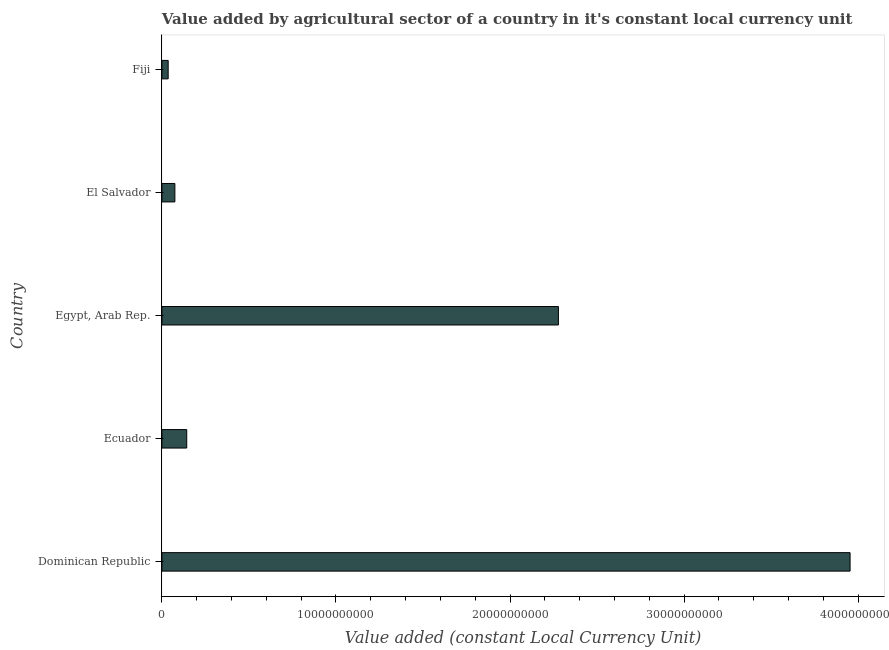Does the graph contain any zero values?
Your answer should be compact. No. What is the title of the graph?
Offer a terse response. Value added by agricultural sector of a country in it's constant local currency unit. What is the label or title of the X-axis?
Give a very brief answer. Value added (constant Local Currency Unit). What is the value added by agriculture sector in Fiji?
Provide a short and direct response. 3.60e+08. Across all countries, what is the maximum value added by agriculture sector?
Your answer should be compact. 3.95e+1. Across all countries, what is the minimum value added by agriculture sector?
Offer a terse response. 3.60e+08. In which country was the value added by agriculture sector maximum?
Ensure brevity in your answer.  Dominican Republic. In which country was the value added by agriculture sector minimum?
Your answer should be very brief. Fiji. What is the sum of the value added by agriculture sector?
Provide a short and direct response. 6.48e+1. What is the difference between the value added by agriculture sector in Egypt, Arab Rep. and El Salvador?
Make the answer very short. 2.20e+1. What is the average value added by agriculture sector per country?
Give a very brief answer. 1.30e+1. What is the median value added by agriculture sector?
Your answer should be compact. 1.43e+09. What is the ratio of the value added by agriculture sector in Dominican Republic to that in Fiji?
Give a very brief answer. 109.82. What is the difference between the highest and the second highest value added by agriculture sector?
Offer a terse response. 1.68e+1. What is the difference between the highest and the lowest value added by agriculture sector?
Your answer should be very brief. 3.92e+1. In how many countries, is the value added by agriculture sector greater than the average value added by agriculture sector taken over all countries?
Provide a succinct answer. 2. How many countries are there in the graph?
Offer a very short reply. 5. What is the Value added (constant Local Currency Unit) in Dominican Republic?
Ensure brevity in your answer.  3.95e+1. What is the Value added (constant Local Currency Unit) of Ecuador?
Ensure brevity in your answer.  1.43e+09. What is the Value added (constant Local Currency Unit) of Egypt, Arab Rep.?
Make the answer very short. 2.28e+1. What is the Value added (constant Local Currency Unit) in El Salvador?
Make the answer very short. 7.45e+08. What is the Value added (constant Local Currency Unit) of Fiji?
Provide a succinct answer. 3.60e+08. What is the difference between the Value added (constant Local Currency Unit) in Dominican Republic and Ecuador?
Provide a short and direct response. 3.81e+1. What is the difference between the Value added (constant Local Currency Unit) in Dominican Republic and Egypt, Arab Rep.?
Provide a short and direct response. 1.68e+1. What is the difference between the Value added (constant Local Currency Unit) in Dominican Republic and El Salvador?
Make the answer very short. 3.88e+1. What is the difference between the Value added (constant Local Currency Unit) in Dominican Republic and Fiji?
Provide a short and direct response. 3.92e+1. What is the difference between the Value added (constant Local Currency Unit) in Ecuador and Egypt, Arab Rep.?
Your response must be concise. -2.14e+1. What is the difference between the Value added (constant Local Currency Unit) in Ecuador and El Salvador?
Provide a short and direct response. 6.81e+08. What is the difference between the Value added (constant Local Currency Unit) in Ecuador and Fiji?
Your answer should be very brief. 1.07e+09. What is the difference between the Value added (constant Local Currency Unit) in Egypt, Arab Rep. and El Salvador?
Provide a succinct answer. 2.20e+1. What is the difference between the Value added (constant Local Currency Unit) in Egypt, Arab Rep. and Fiji?
Offer a very short reply. 2.24e+1. What is the difference between the Value added (constant Local Currency Unit) in El Salvador and Fiji?
Your answer should be compact. 3.85e+08. What is the ratio of the Value added (constant Local Currency Unit) in Dominican Republic to that in Ecuador?
Offer a terse response. 27.71. What is the ratio of the Value added (constant Local Currency Unit) in Dominican Republic to that in Egypt, Arab Rep.?
Your response must be concise. 1.74. What is the ratio of the Value added (constant Local Currency Unit) in Dominican Republic to that in El Salvador?
Give a very brief answer. 53.05. What is the ratio of the Value added (constant Local Currency Unit) in Dominican Republic to that in Fiji?
Your answer should be very brief. 109.82. What is the ratio of the Value added (constant Local Currency Unit) in Ecuador to that in Egypt, Arab Rep.?
Your answer should be very brief. 0.06. What is the ratio of the Value added (constant Local Currency Unit) in Ecuador to that in El Salvador?
Provide a short and direct response. 1.92. What is the ratio of the Value added (constant Local Currency Unit) in Ecuador to that in Fiji?
Offer a terse response. 3.96. What is the ratio of the Value added (constant Local Currency Unit) in Egypt, Arab Rep. to that in El Salvador?
Ensure brevity in your answer.  30.57. What is the ratio of the Value added (constant Local Currency Unit) in Egypt, Arab Rep. to that in Fiji?
Offer a terse response. 63.27. What is the ratio of the Value added (constant Local Currency Unit) in El Salvador to that in Fiji?
Provide a short and direct response. 2.07. 